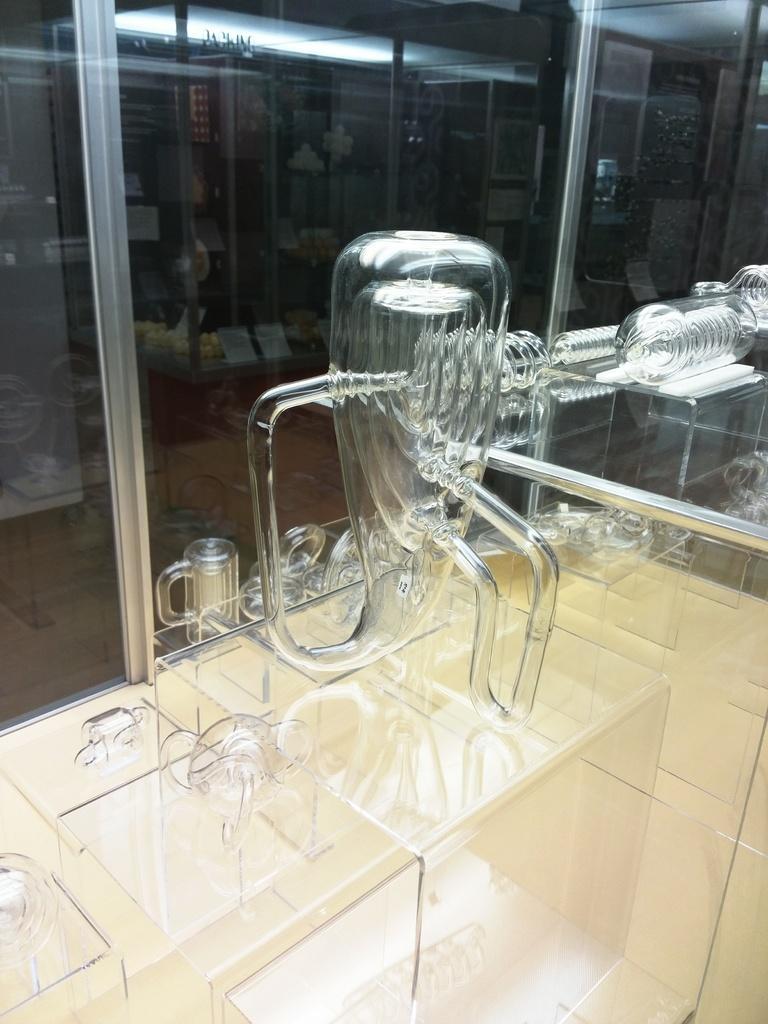Please provide a concise description of this image. In this picture I can see there is a glass utensil and it is placed on a surface and in the backdrop there is a glass window. 